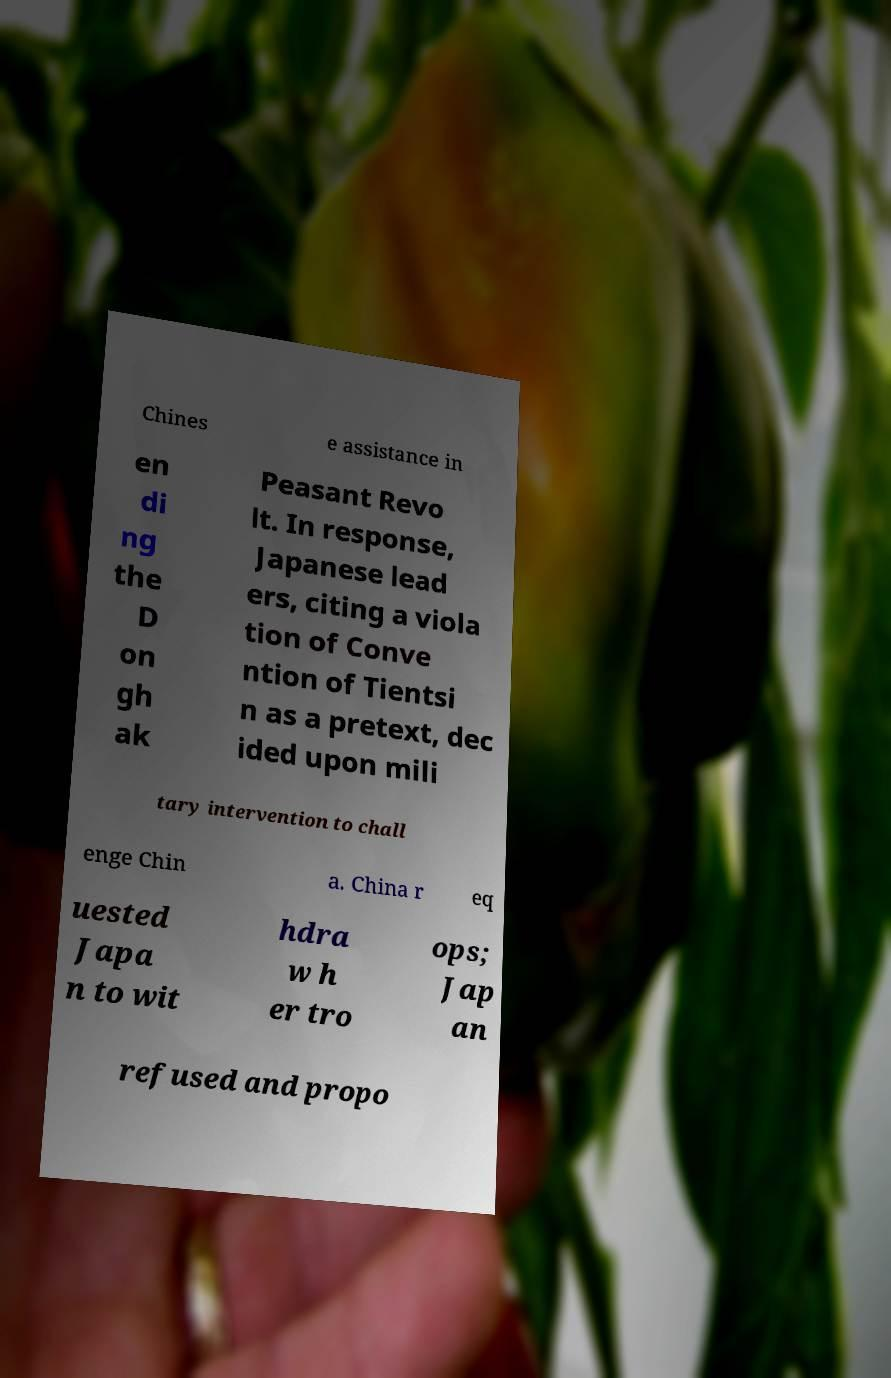Please read and relay the text visible in this image. What does it say? Chines e assistance in en di ng the D on gh ak Peasant Revo lt. In response, Japanese lead ers, citing a viola tion of Conve ntion of Tientsi n as a pretext, dec ided upon mili tary intervention to chall enge Chin a. China r eq uested Japa n to wit hdra w h er tro ops; Jap an refused and propo 